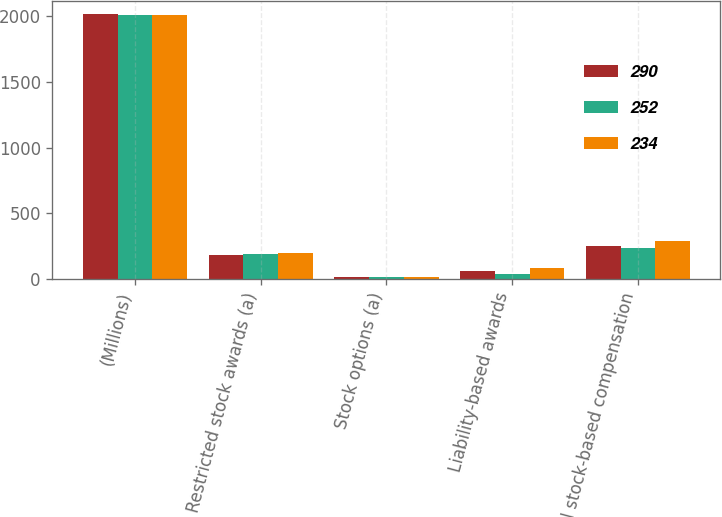<chart> <loc_0><loc_0><loc_500><loc_500><stacked_bar_chart><ecel><fcel>(Millions)<fcel>Restricted stock awards (a)<fcel>Stock options (a)<fcel>Liability-based awards<fcel>Total stock-based compensation<nl><fcel>290<fcel>2016<fcel>178<fcel>14<fcel>60<fcel>252<nl><fcel>252<fcel>2015<fcel>190<fcel>12<fcel>32<fcel>234<nl><fcel>234<fcel>2014<fcel>193<fcel>13<fcel>84<fcel>290<nl></chart> 